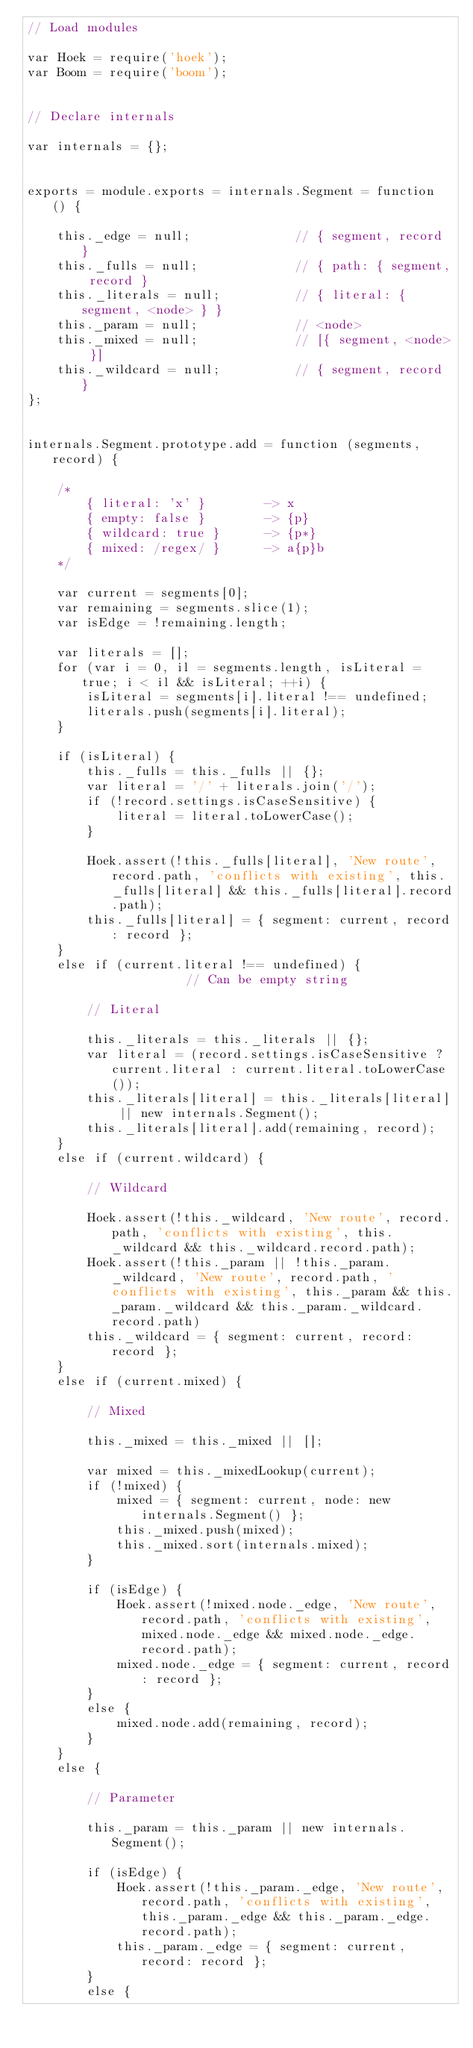Convert code to text. <code><loc_0><loc_0><loc_500><loc_500><_JavaScript_>// Load modules

var Hoek = require('hoek');
var Boom = require('boom');


// Declare internals

var internals = {};


exports = module.exports = internals.Segment = function () {

    this._edge = null;              // { segment, record }
    this._fulls = null;             // { path: { segment, record }
    this._literals = null;          // { literal: { segment, <node> } }
    this._param = null;             // <node>
    this._mixed = null;             // [{ segment, <node> }]
    this._wildcard = null;          // { segment, record }
};


internals.Segment.prototype.add = function (segments, record) {

    /*
        { literal: 'x' }        -> x
        { empty: false }        -> {p}
        { wildcard: true }      -> {p*}
        { mixed: /regex/ }      -> a{p}b
    */

    var current = segments[0];
    var remaining = segments.slice(1);
    var isEdge = !remaining.length;

    var literals = [];
    for (var i = 0, il = segments.length, isLiteral = true; i < il && isLiteral; ++i) {
        isLiteral = segments[i].literal !== undefined;
        literals.push(segments[i].literal);
    }

    if (isLiteral) {
        this._fulls = this._fulls || {};
        var literal = '/' + literals.join('/');
        if (!record.settings.isCaseSensitive) {
            literal = literal.toLowerCase();
        }

        Hoek.assert(!this._fulls[literal], 'New route', record.path, 'conflicts with existing', this._fulls[literal] && this._fulls[literal].record.path);
        this._fulls[literal] = { segment: current, record: record };
    }
    else if (current.literal !== undefined) {               // Can be empty string

        // Literal

        this._literals = this._literals || {};
        var literal = (record.settings.isCaseSensitive ? current.literal : current.literal.toLowerCase());
        this._literals[literal] = this._literals[literal] || new internals.Segment();
        this._literals[literal].add(remaining, record);
    }
    else if (current.wildcard) {

        // Wildcard

        Hoek.assert(!this._wildcard, 'New route', record.path, 'conflicts with existing', this._wildcard && this._wildcard.record.path);
        Hoek.assert(!this._param || !this._param._wildcard, 'New route', record.path, 'conflicts with existing', this._param && this._param._wildcard && this._param._wildcard.record.path)
        this._wildcard = { segment: current, record: record };
    }
    else if (current.mixed) {

        // Mixed

        this._mixed = this._mixed || [];

        var mixed = this._mixedLookup(current);
        if (!mixed) {
            mixed = { segment: current, node: new internals.Segment() };
            this._mixed.push(mixed);
            this._mixed.sort(internals.mixed);
        }

        if (isEdge) {
            Hoek.assert(!mixed.node._edge, 'New route', record.path, 'conflicts with existing', mixed.node._edge && mixed.node._edge.record.path);
            mixed.node._edge = { segment: current, record: record };
        }
        else {
            mixed.node.add(remaining, record);
        }
    }
    else {

        // Parameter

        this._param = this._param || new internals.Segment();

        if (isEdge) {
            Hoek.assert(!this._param._edge, 'New route', record.path, 'conflicts with existing', this._param._edge && this._param._edge.record.path);
            this._param._edge = { segment: current, record: record };
        }
        else {</code> 